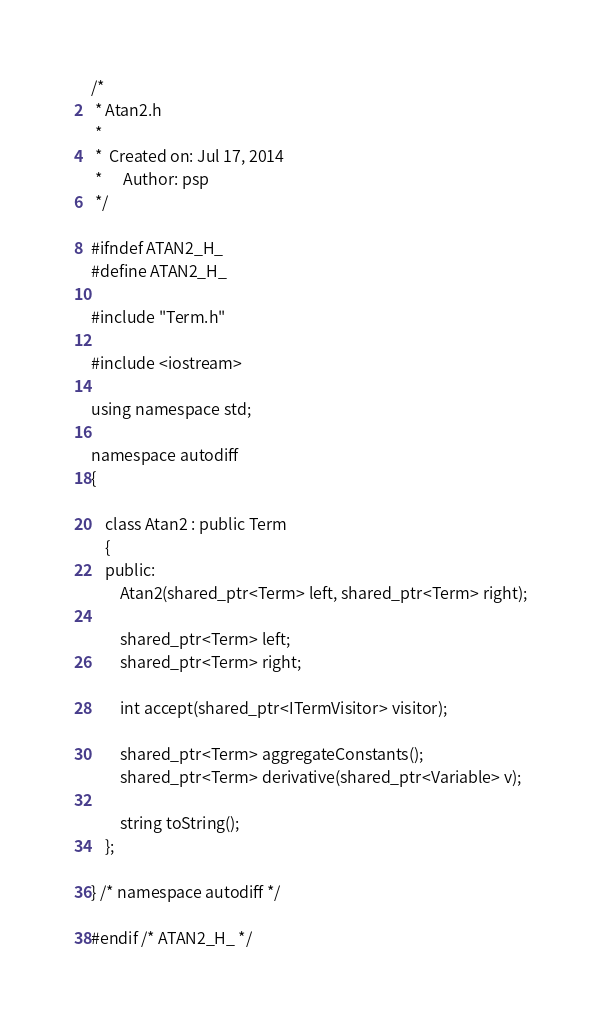<code> <loc_0><loc_0><loc_500><loc_500><_C_>/*
 * Atan2.h
 *
 *  Created on: Jul 17, 2014
 *      Author: psp
 */

#ifndef ATAN2_H_
#define ATAN2_H_

#include "Term.h"

#include <iostream>

using namespace std;

namespace autodiff
{

	class Atan2 : public Term
	{
	public:
		Atan2(shared_ptr<Term> left, shared_ptr<Term> right);

		shared_ptr<Term> left;
		shared_ptr<Term> right;

		int accept(shared_ptr<ITermVisitor> visitor);

		shared_ptr<Term> aggregateConstants();
		shared_ptr<Term> derivative(shared_ptr<Variable> v);

		string toString();
	};

} /* namespace autodiff */

#endif /* ATAN2_H_ */
</code> 